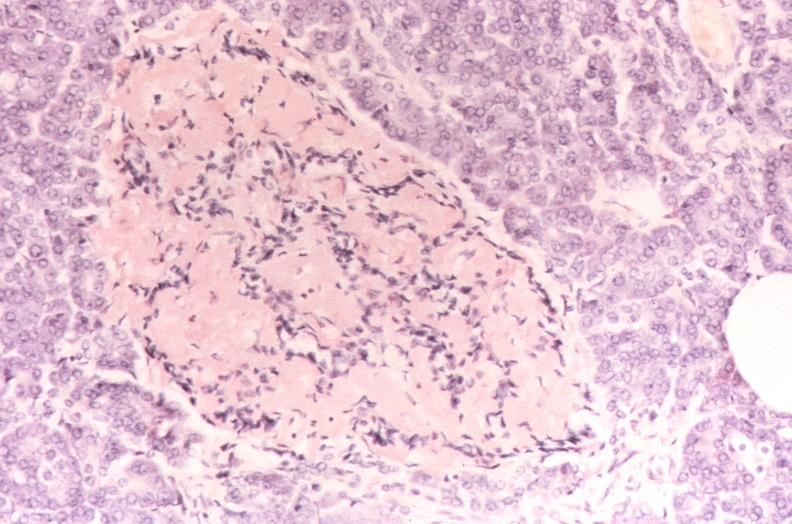where is this?
Answer the question using a single word or phrase. Pancreas 